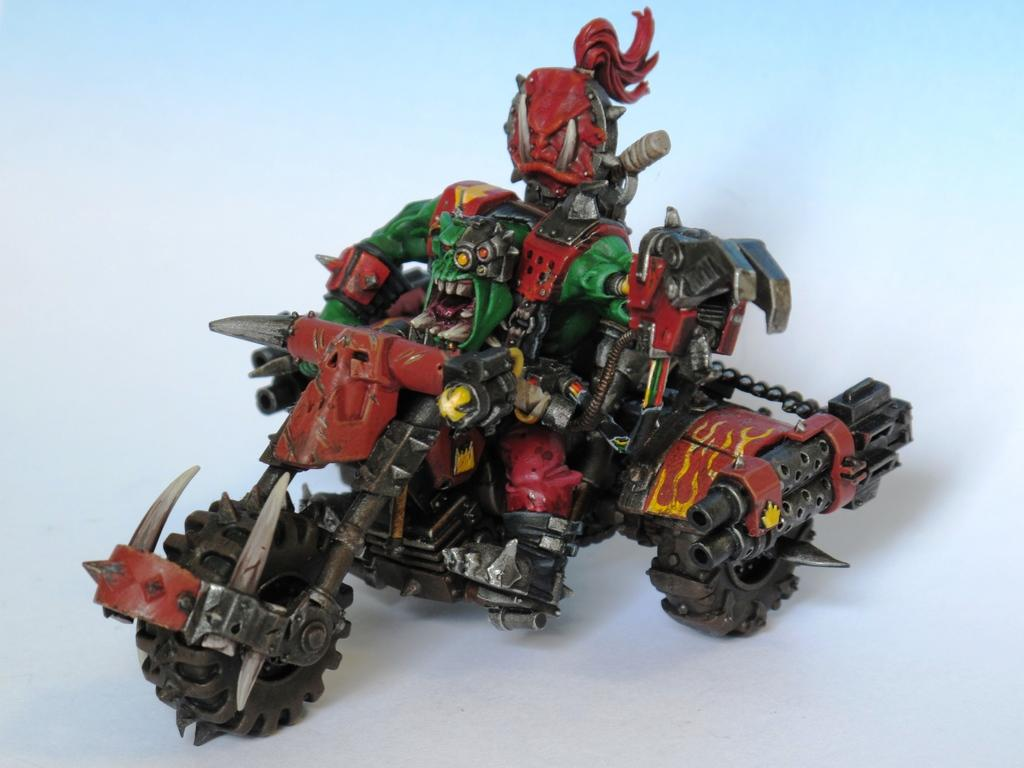What type of toy is present in the image? There is a toy tricycle in the image. Can you describe the position of the toy tricycle? The toy tricycle is placed on a surface. How comfortable is the gate for the toy tricycle in the image? There is no gate present in the image, so it is not possible to determine its comfort for the toy tricycle. 